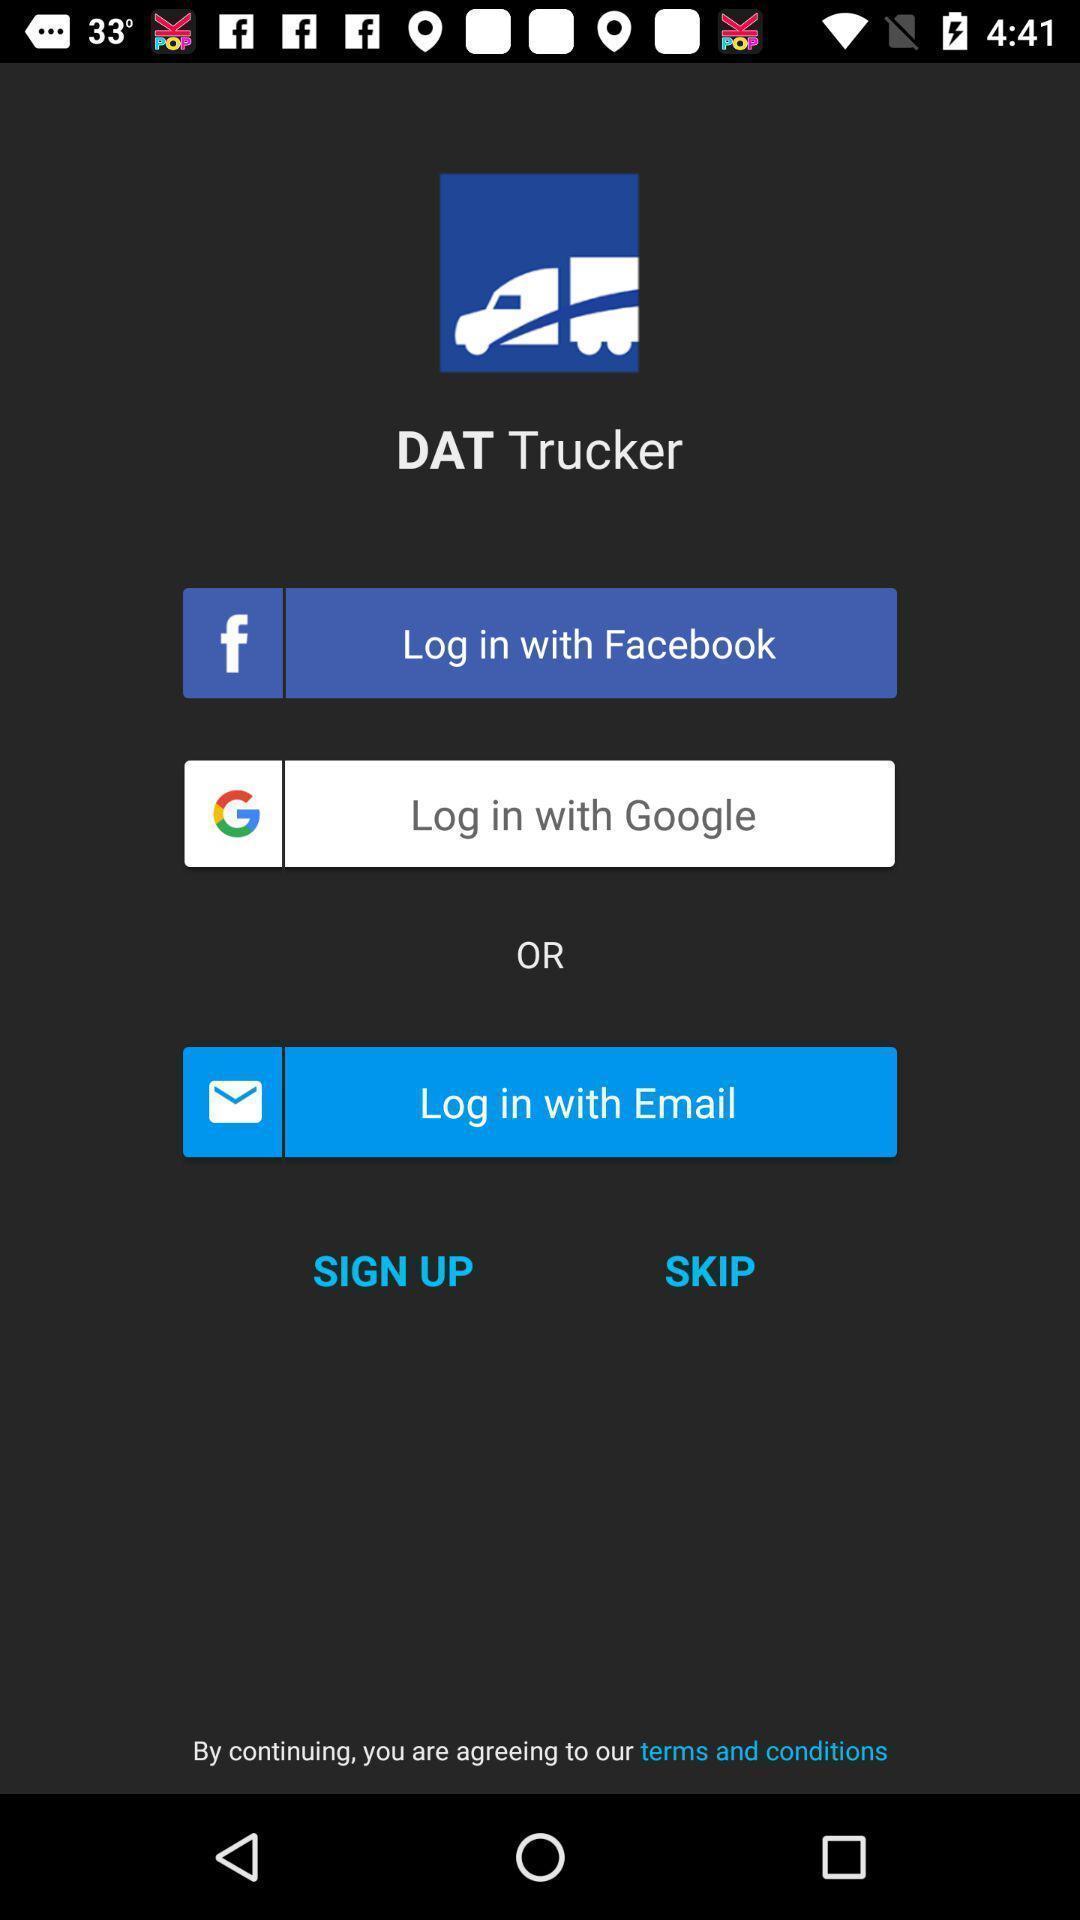Describe the key features of this screenshot. Page showing about different login option. 